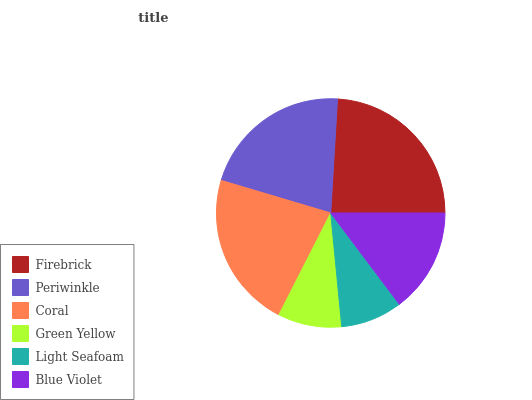Is Light Seafoam the minimum?
Answer yes or no. Yes. Is Firebrick the maximum?
Answer yes or no. Yes. Is Periwinkle the minimum?
Answer yes or no. No. Is Periwinkle the maximum?
Answer yes or no. No. Is Firebrick greater than Periwinkle?
Answer yes or no. Yes. Is Periwinkle less than Firebrick?
Answer yes or no. Yes. Is Periwinkle greater than Firebrick?
Answer yes or no. No. Is Firebrick less than Periwinkle?
Answer yes or no. No. Is Periwinkle the high median?
Answer yes or no. Yes. Is Blue Violet the low median?
Answer yes or no. Yes. Is Coral the high median?
Answer yes or no. No. Is Firebrick the low median?
Answer yes or no. No. 